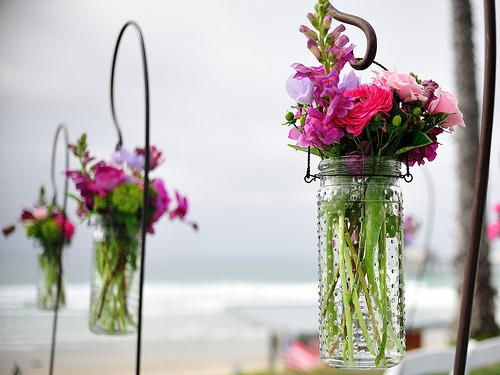Question: where was this picture taken?
Choices:
A. Mountain.
B. Prairie.
C. Beach.
D. Jungle.
Answer with the letter. Answer: C Question: what colors are the flowers?
Choices:
A. Green.
B. Pink, purple and white.
C. Blue.
D. Yellow and white.
Answer with the letter. Answer: B Question: what is that tall thing on the right side of picture?
Choices:
A. Light pole.
B. Flagpole.
C. Signpost.
D. Tree.
Answer with the letter. Answer: D Question: what is that in the background?
Choices:
A. Ocean.
B. Mountains.
C. City.
D. Highway.
Answer with the letter. Answer: A 